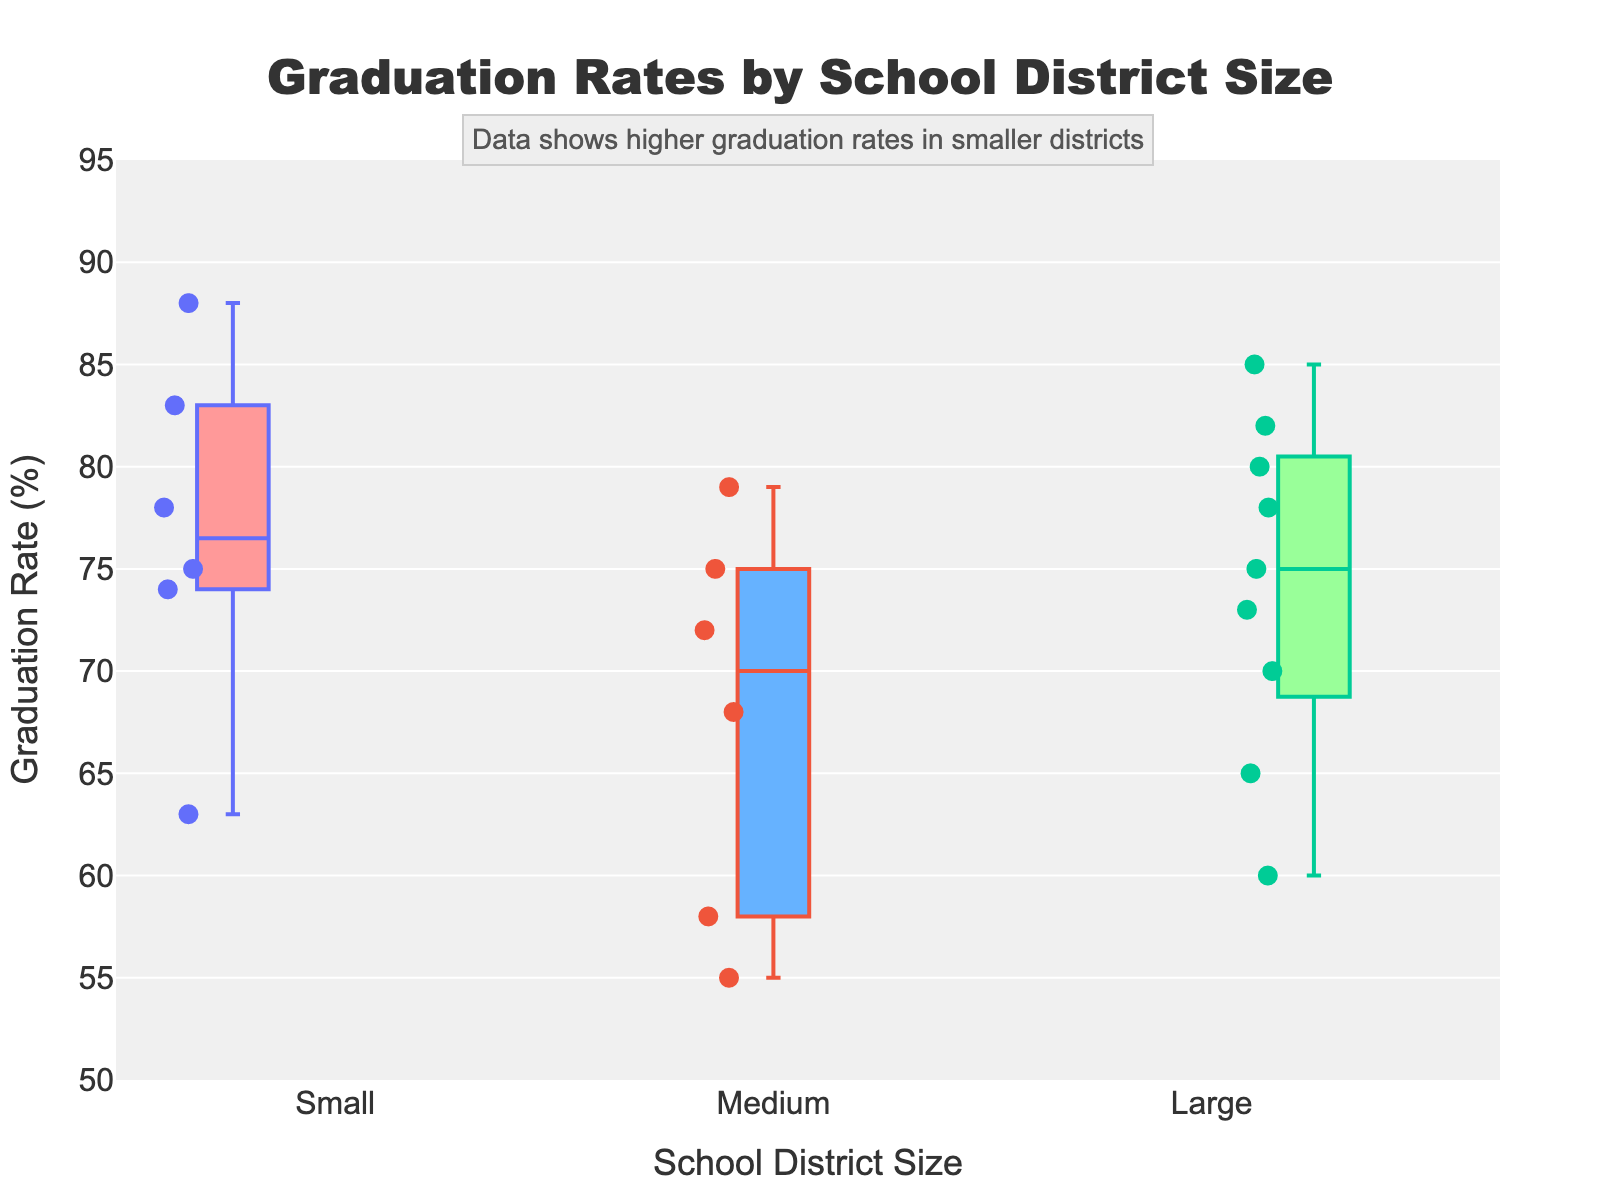What is the title of the plot? The title is typically placed at the top of the figure. In this figure, it reads "Graduation Rates by School District Size".
Answer: Graduation Rates by School District Size What is the range of the y-axis? The y-axis represents graduation rates, and it ranges from 50 to 95 as indicated by the axis ticks and label.
Answer: 50 to 95 How many different categories for the school district size are displayed on the x-axis? The x-axis is divided into three distinct categories representing different school district sizes: Small, Medium, and Large.
Answer: 3 Which school district size has the highest median graduation rate? To determine the highest median graduation rate, we look at the lines inside the boxes for Small, Medium, and Large. The Small district size shows the highest median line.
Answer: Small How many graduation rates are plotted for Large school districts? Each data point is plotted as a mark within the box plot. For the Large school district size, there are nine graduation rates plotted (3 per socioeconomic status).
Answer: 9 What is the difference between the highest and lowest graduation rates in Medium school districts? The highest graduation rate in Medium districts is 79%, and the lowest is 55%. The difference is calculated as 79 - 55.
Answer: 24 Which school district size has the most variability in graduation rates? Variability is determined by the spread of the box and whiskers. Medium districts have the widest box and whiskers, indicating the most variability.
Answer: Medium How does the graduation rate for high socioeconomic status compare across different school district sizes? Look at the top positions of the boxes and individual points for each size. High socioeconomic status in Small districts shows the highest rates, followed by Large, then Medium.
Answer: Small > Large > Medium Is there a visible trend in graduation rates concerning school district size? Analyzing the overall position and distribution of the boxes: Smaller districts generally have higher graduation rates, followed by Medium and then Large districts.
Answer: Smaller districts have higher rates What is the highest graduation rate for all school district sizes and socioeconomic statuses? By examining each category, the highest graduation rate data point across all sizes and statuses is 88% in the Small district size for high socioeconomic status.
Answer: 88 